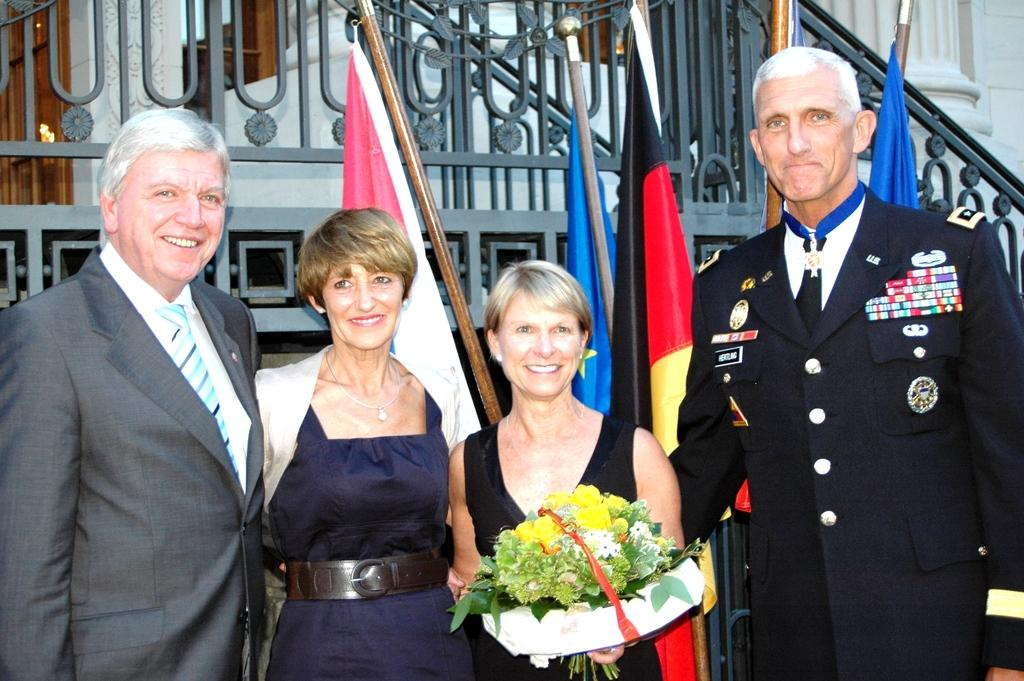What are the people in the image doing? The people in the image are standing. What is the lady holding in the image? The lady is holding a bouquet. What can be seen in the background of the image? There are flags, a metal railing, a wall, and a pillar in the background of the image. What type of wine is being served at the accountant's office in the image? There is no wine or accountant's office present in the image. Can you tell me how many flies are buzzing around the pillar in the image? There are no flies visible in the image. 